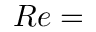Convert formula to latex. <formula><loc_0><loc_0><loc_500><loc_500>R e =</formula> 